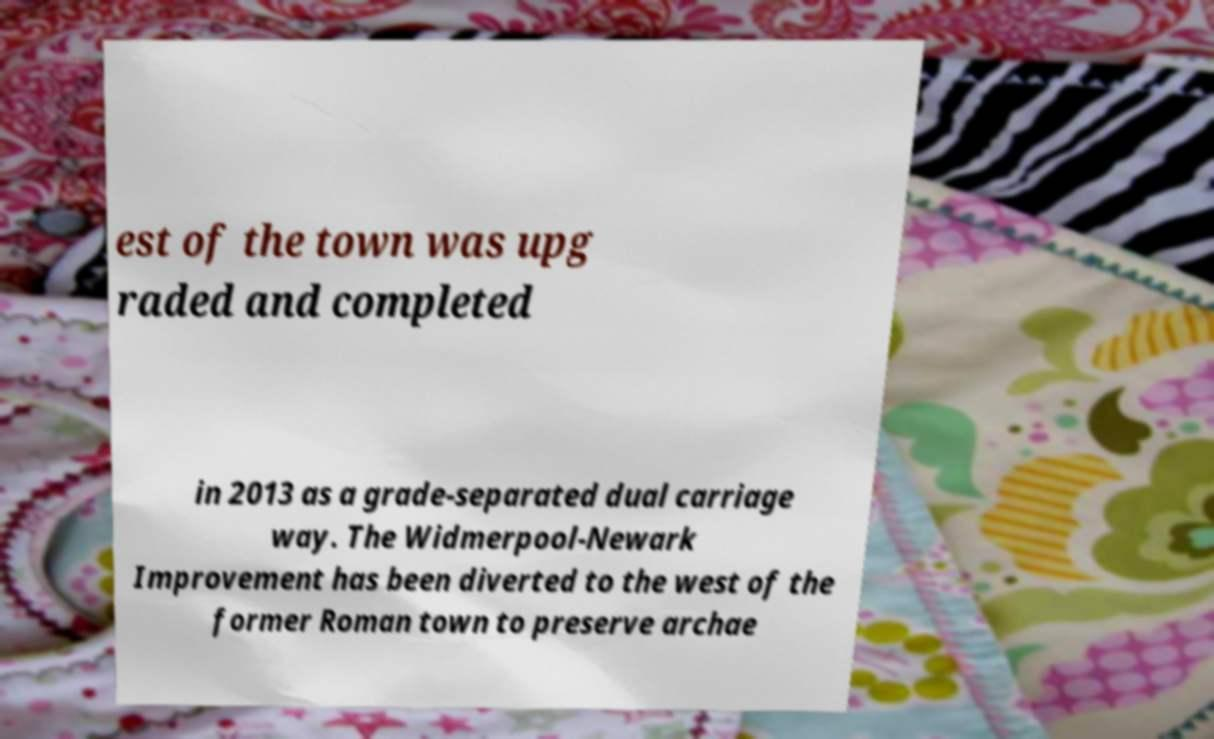I need the written content from this picture converted into text. Can you do that? est of the town was upg raded and completed in 2013 as a grade-separated dual carriage way. The Widmerpool-Newark Improvement has been diverted to the west of the former Roman town to preserve archae 